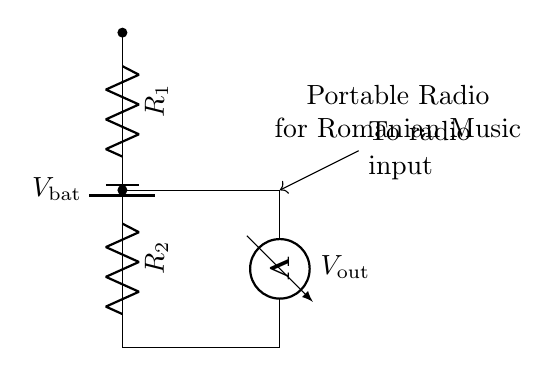What type of circuit is this? This circuit is a voltage divider, which is used to divide the input voltage into smaller voltages based on the resistance values.
Answer: Voltage divider What do R1 and R2 represent? R1 and R2 are resistors in the circuit that determine the output voltage based on their values.
Answer: Resistors What is connected to the output of the voltage divider? The output is connected to a voltmeter that measures the output voltage for the portable radio.
Answer: Voltmeter What is the purpose of this circuit? The purpose is to provide a specific voltage output for the portable radio to operate correctly.
Answer: Voltage output for radio What is Vout? Vout is the output voltage of the voltage divider, which is the voltage measured across R2.
Answer: Output voltage How is the output voltage determined? The output voltage is determined by the ratio of the resistances R1 and R2 relative to the input voltage, according to the voltage divider formula.
Answer: Ratio of resistances Which component provides the power for the circuit? The battery provides the electrical power required for the circuit operation.
Answer: Battery 